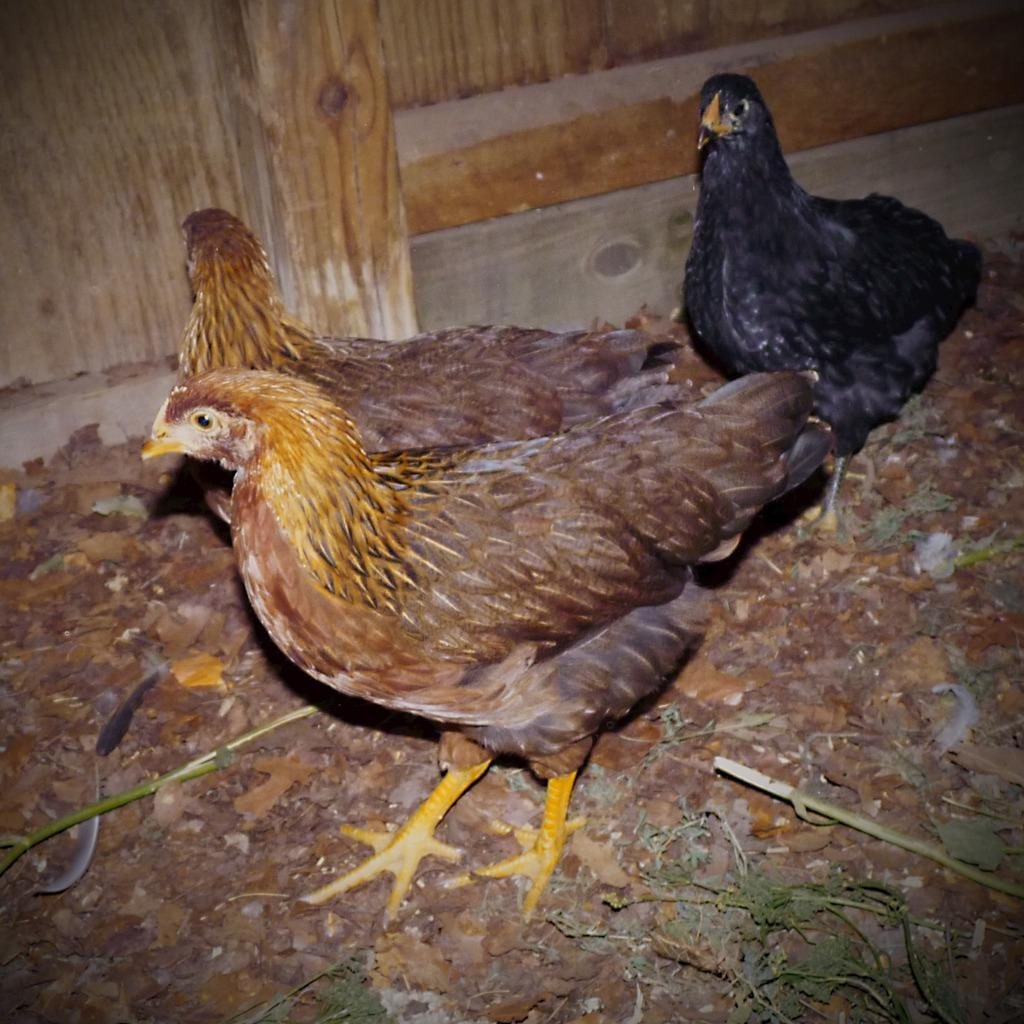How many hens are present in the image? There are three hens in the image. What is located behind the hens in the image? There is a wooden surface behind the hens. What type of boat can be seen in the image? There is no boat present in the image; it features three hens and a wooden surface. How does the digestion process of the hens appear in the image? The image does not show the digestion process of the hens; it only shows their physical appearance and the wooden surface behind them. 